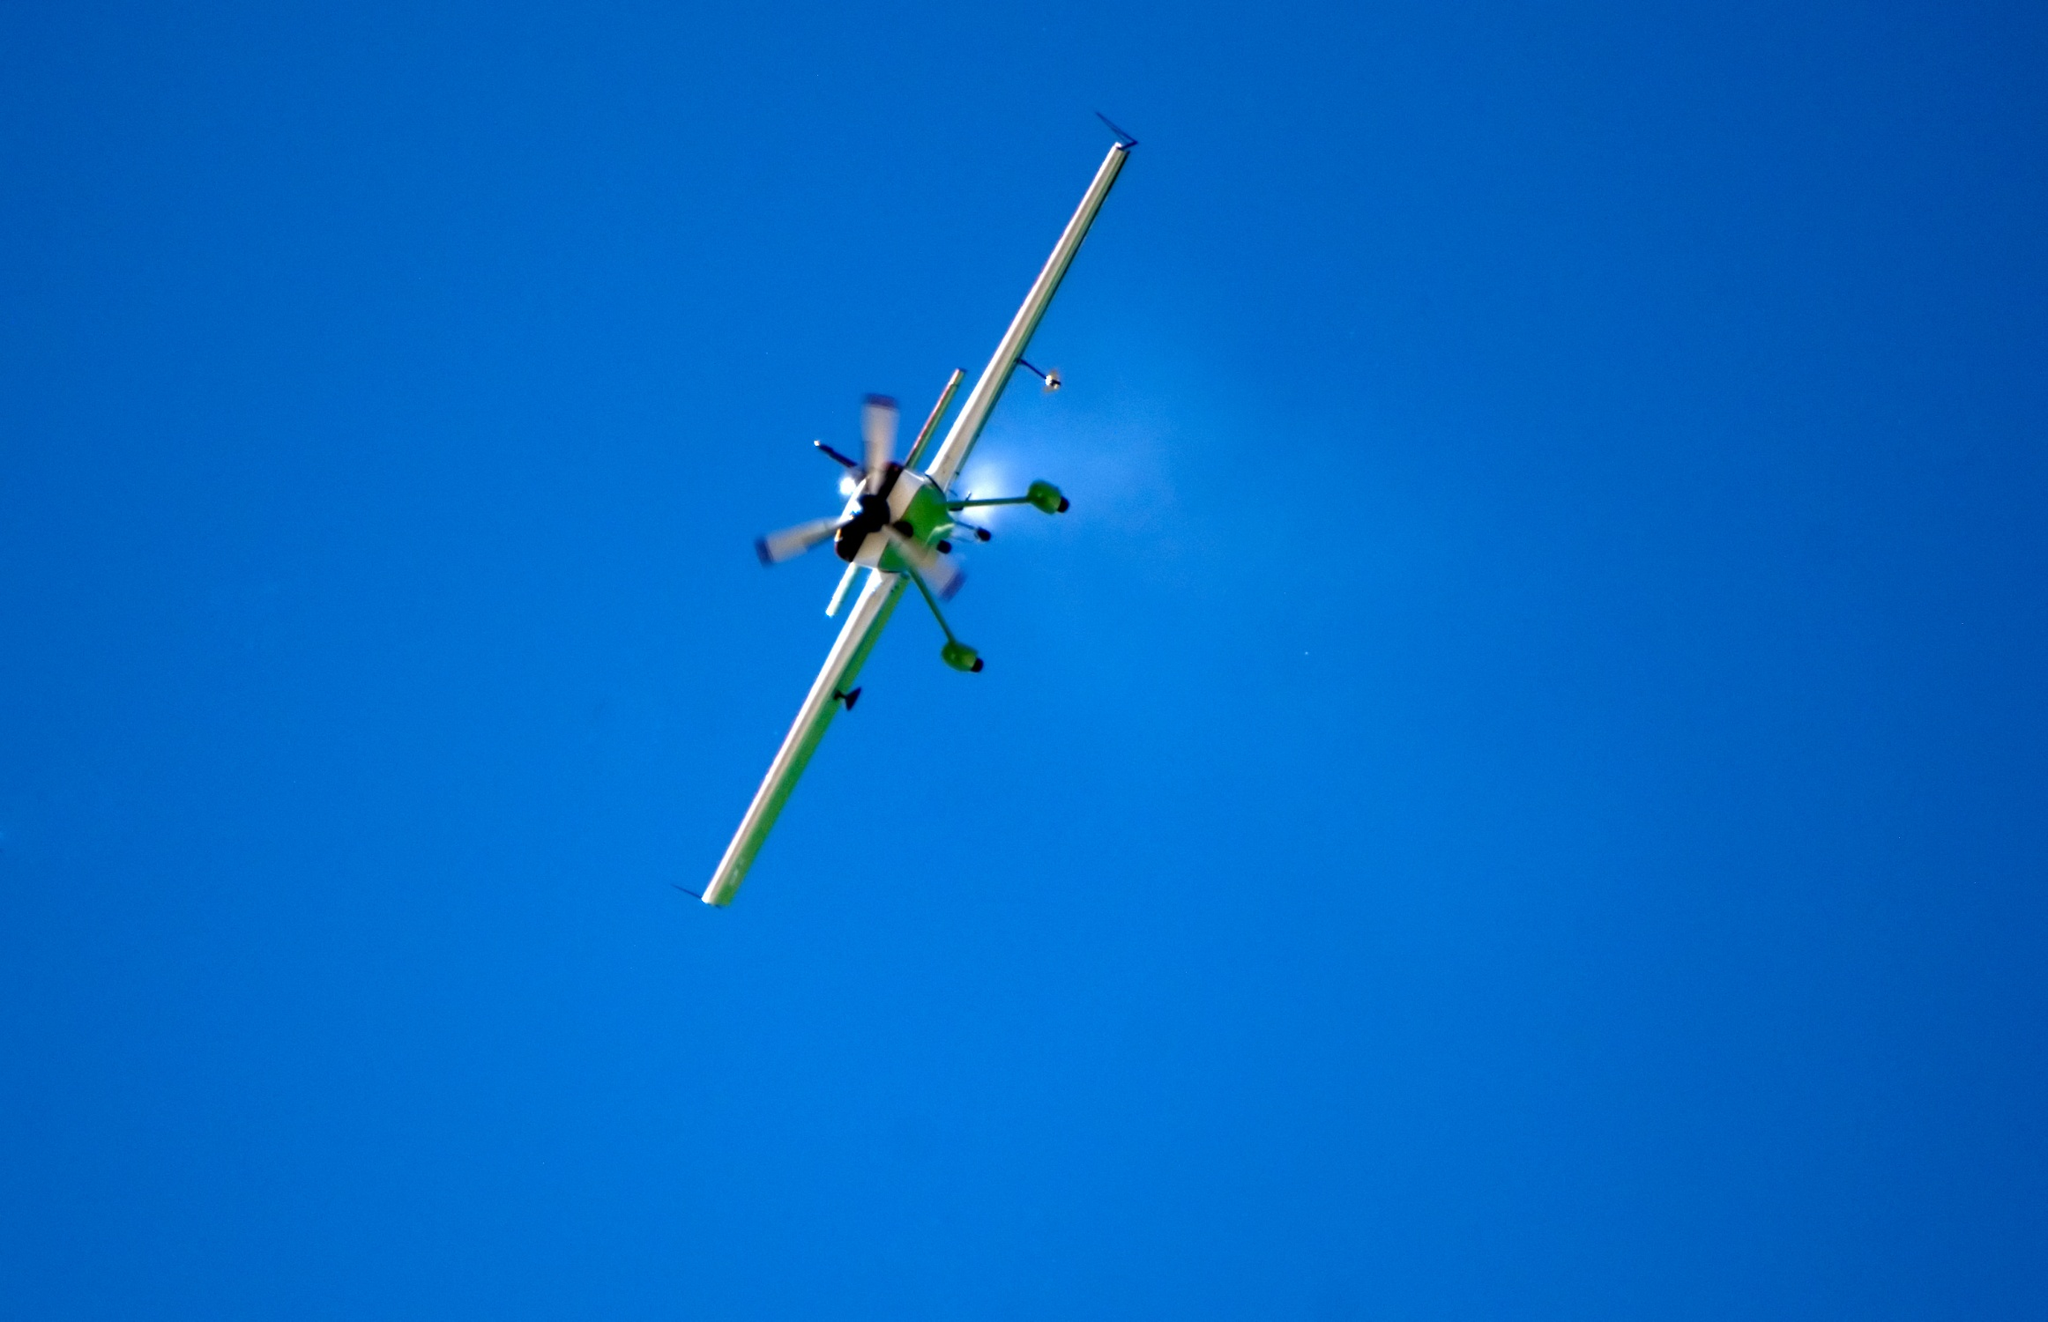Can you describe the main features of this image for me?
 In the clear blue sky, a small airplane is captured in mid-flight. The airplane, painted in a crisp white with accents of green on the propeller and tail, stands out against the azure backdrop. The body of the airplane, along with its two wings, gleams white under the sunlight. The propeller at the front of the airplane, spinning rapidly, is a vibrant green, matching the color of the tail. The airplane is angled such that its nose is pointing upwards towards the sky, and its tail downwards. As it cuts through the air, it leaves behind a trail of white smoke, marking its path across the sky. The image captures the essence of flight, with the airplane soaring freely in the vast expanse of the sky. 